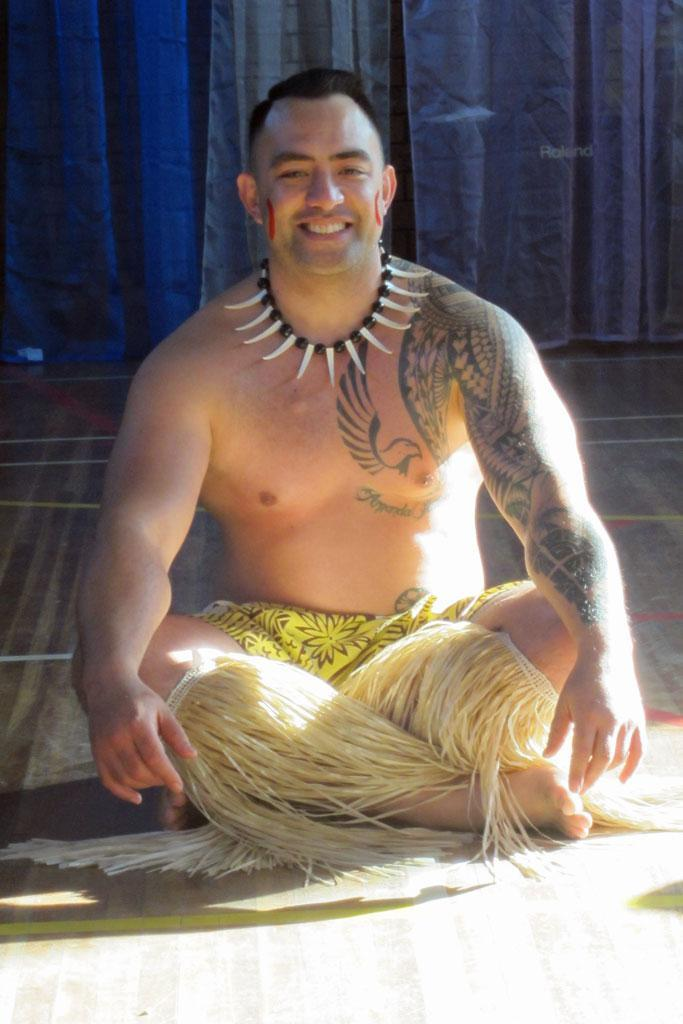Who is present in the image? There is a man in the image. What is the man doing in the image? The man is sitting. What type of clothing is the man wearing in the image? The man is wearing shorts. What type of print can be seen on the man's shirt in the image? The man is not wearing a shirt in the image; he is wearing shorts. 